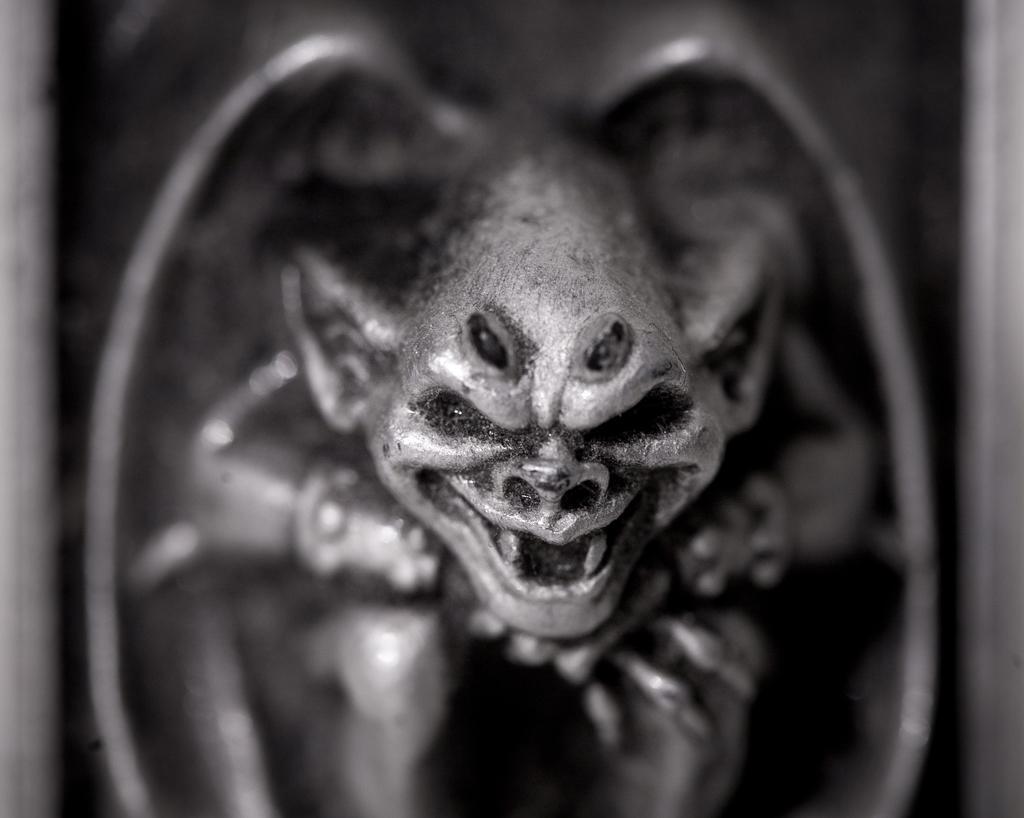Can you describe this image briefly? This is a black and white picture. I can see a sculpture. 